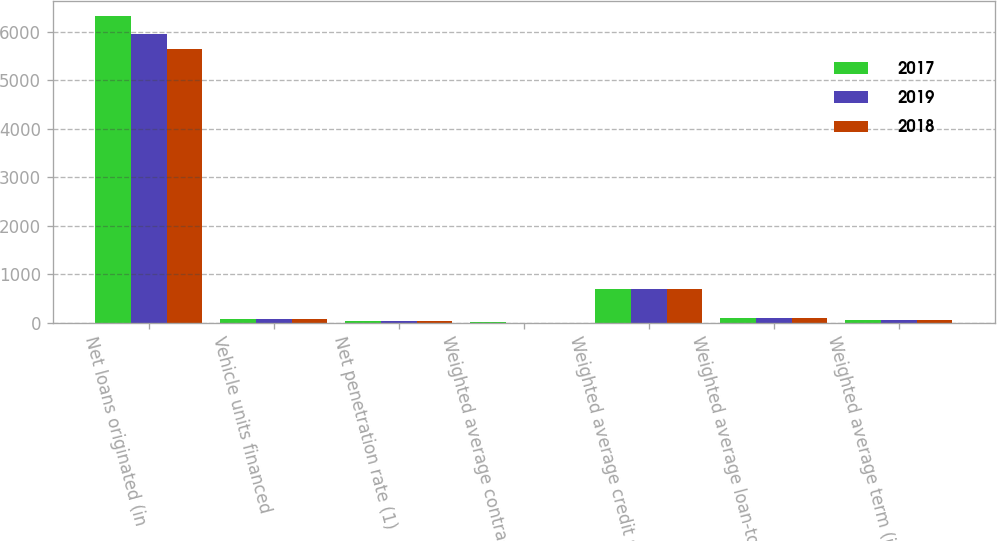Convert chart to OTSL. <chart><loc_0><loc_0><loc_500><loc_500><stacked_bar_chart><ecel><fcel>Net loans originated (in<fcel>Vehicle units financed<fcel>Net penetration rate (1)<fcel>Weighted average contract rate<fcel>Weighted average credit score<fcel>Weighted average loan-to-value<fcel>Weighted average term (in<nl><fcel>2017<fcel>6330.1<fcel>80.4<fcel>43.2<fcel>8.5<fcel>706<fcel>94.8<fcel>66<nl><fcel>2019<fcel>5962.2<fcel>80.4<fcel>43.1<fcel>7.8<fcel>707<fcel>95<fcel>65.8<nl><fcel>2018<fcel>5643.3<fcel>80.4<fcel>44.2<fcel>7.4<fcel>706<fcel>95<fcel>65.8<nl></chart> 